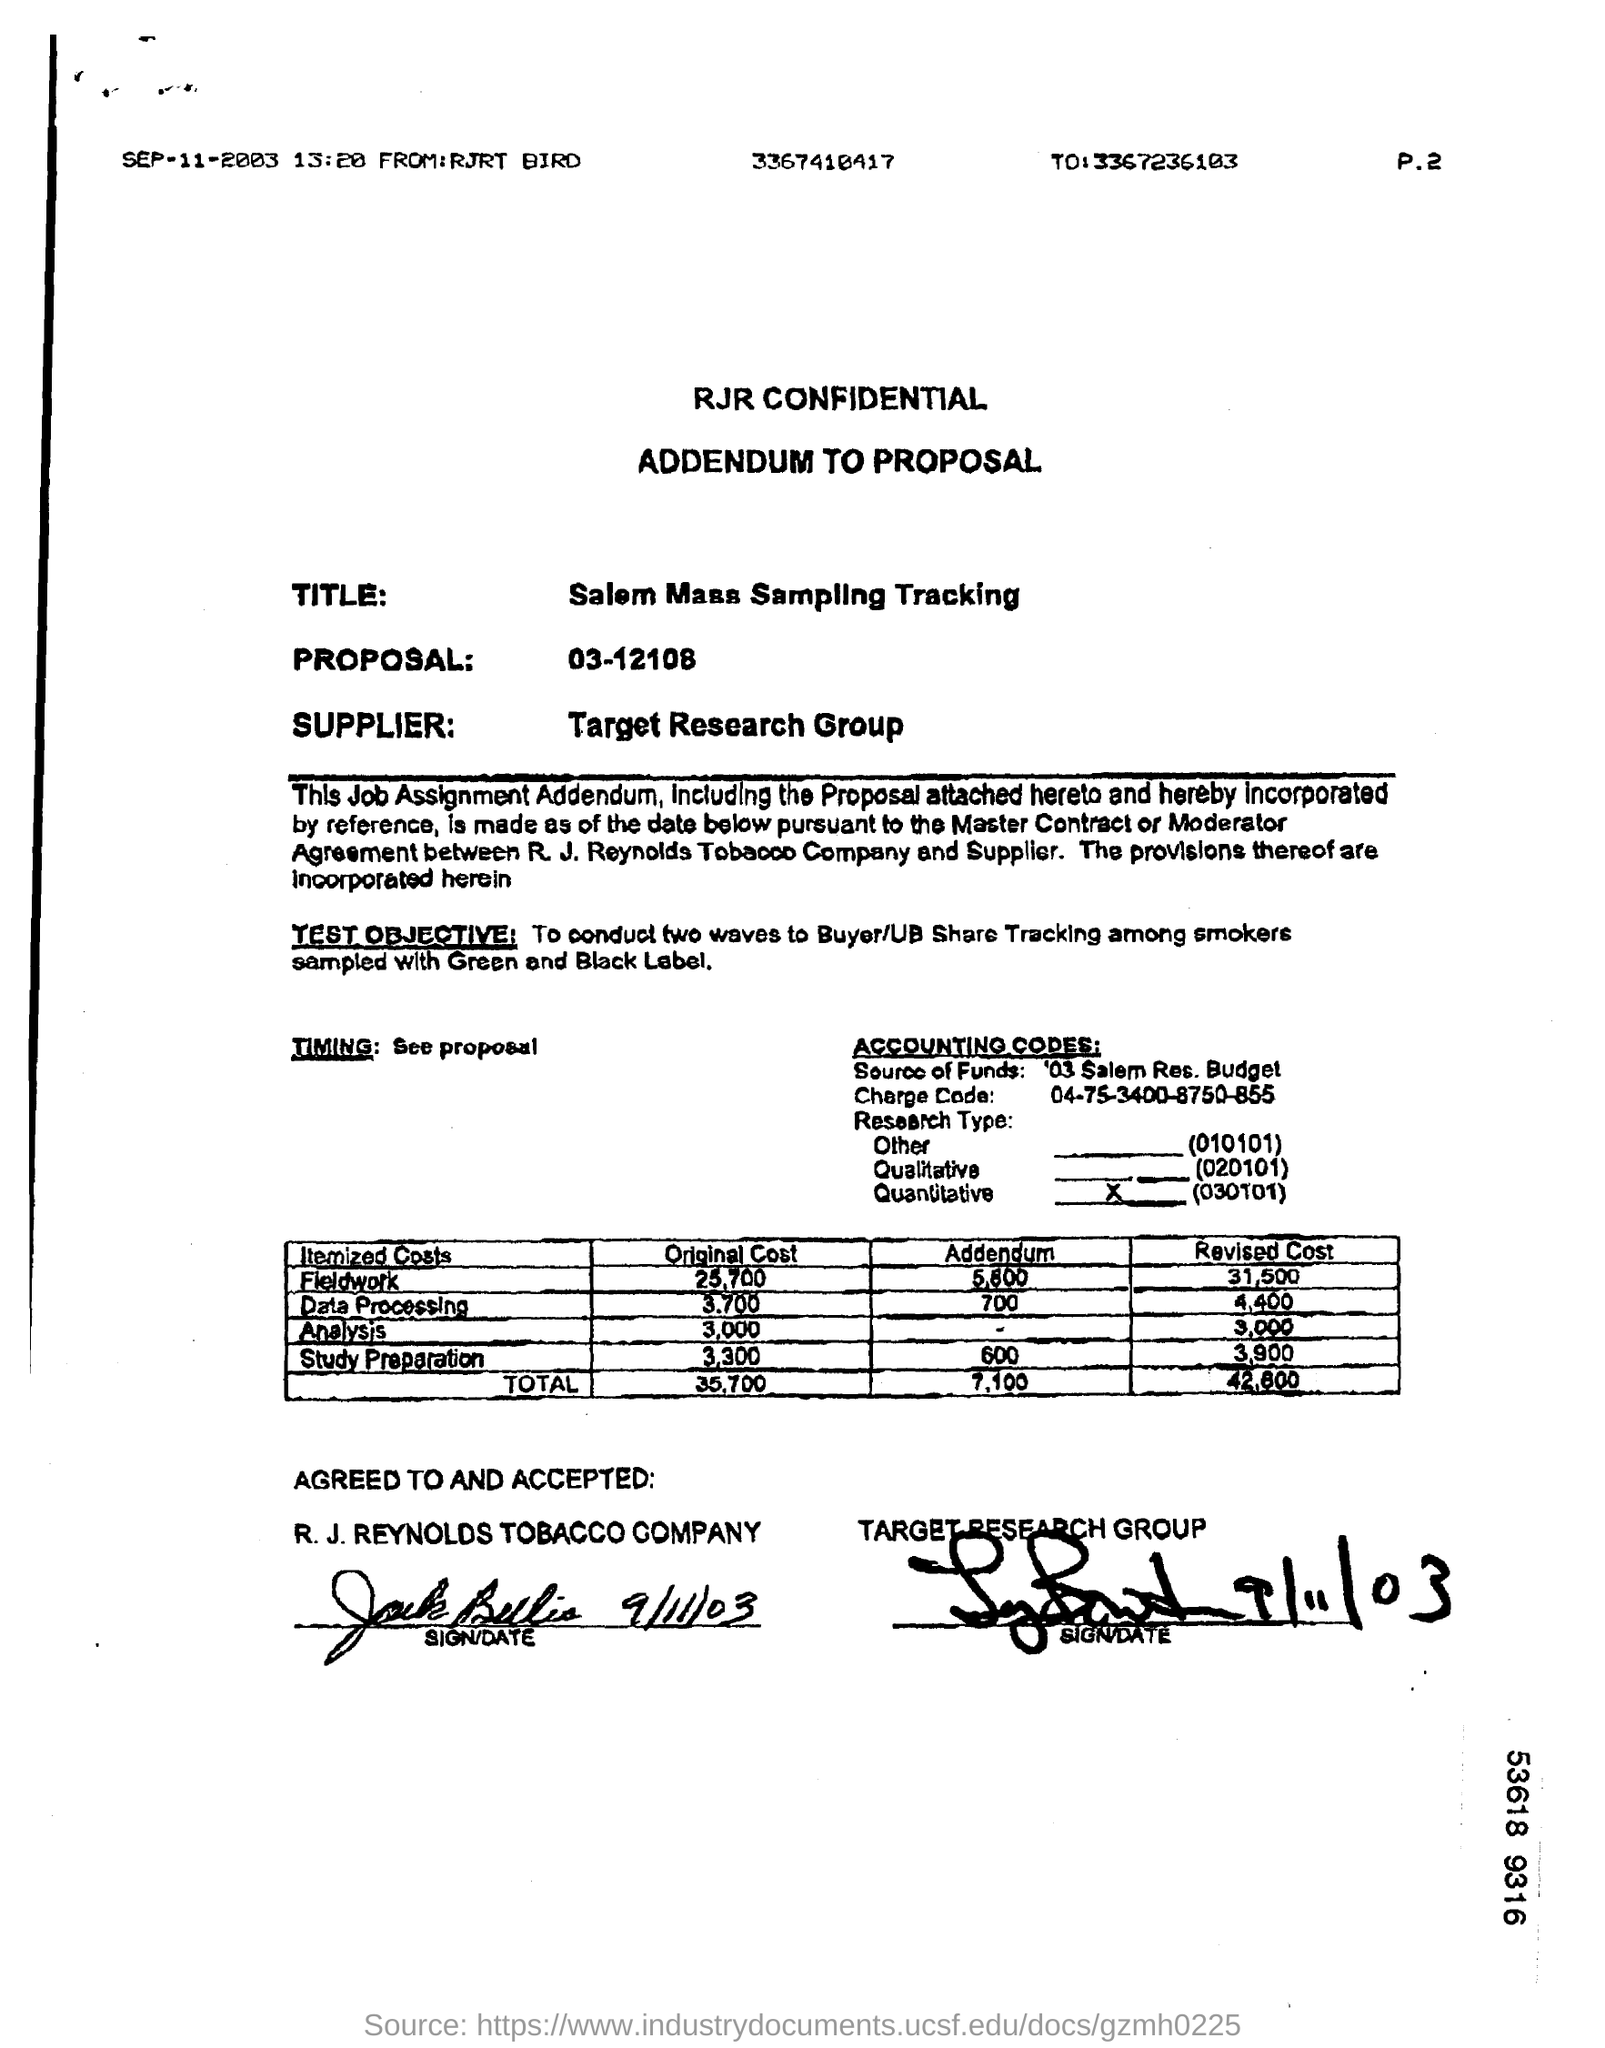Identify some key points in this picture. The supplier is Target Research Group. The addendum for field work is 5,800. The revised cost, as indicated by the total of 42,800, is the sum of all expenses incurred or to be incurred in connection with the project. The title of this document is 'Salem Mass Sampling Tracking.' 